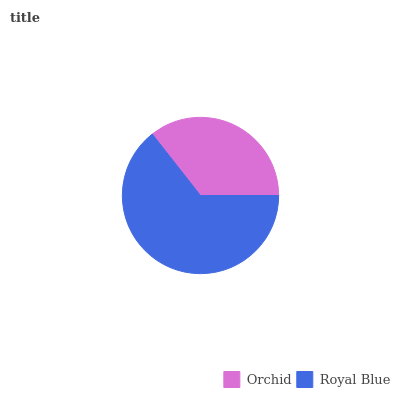Is Orchid the minimum?
Answer yes or no. Yes. Is Royal Blue the maximum?
Answer yes or no. Yes. Is Royal Blue the minimum?
Answer yes or no. No. Is Royal Blue greater than Orchid?
Answer yes or no. Yes. Is Orchid less than Royal Blue?
Answer yes or no. Yes. Is Orchid greater than Royal Blue?
Answer yes or no. No. Is Royal Blue less than Orchid?
Answer yes or no. No. Is Royal Blue the high median?
Answer yes or no. Yes. Is Orchid the low median?
Answer yes or no. Yes. Is Orchid the high median?
Answer yes or no. No. Is Royal Blue the low median?
Answer yes or no. No. 